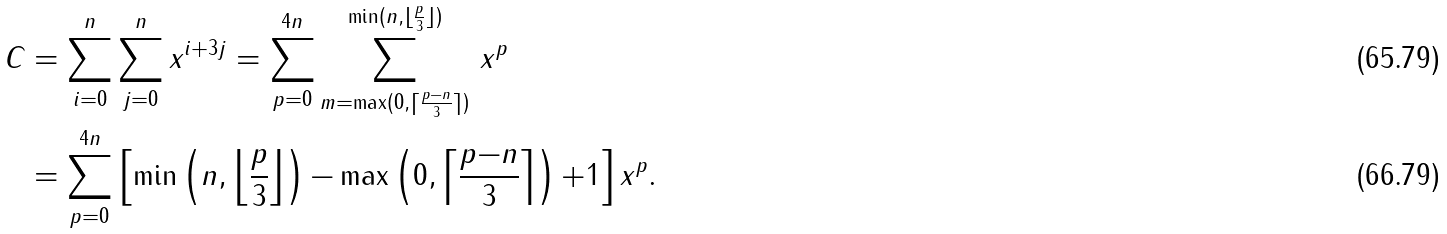Convert formula to latex. <formula><loc_0><loc_0><loc_500><loc_500>C & = \sum _ { i = 0 } ^ { n } \sum _ { j = 0 } ^ { n } x ^ { i + 3 j } = \sum _ { p = 0 } ^ { 4 n } \sum _ { m = \max ( 0 , \lceil \frac { p - n } { 3 } \rceil ) } ^ { \min ( n , \lfloor \frac { p } { 3 } \rfloor ) } \, x ^ { p } \\ & = \sum _ { p = 0 } ^ { 4 n } \left [ \min \left ( n , \left \lfloor \frac { p } { 3 } \right \rfloor \right ) { - } \max \left ( 0 , \left \lceil \frac { p { - } n } { 3 } \right \rceil \right ) { + } 1 \right ] x ^ { p } .</formula> 